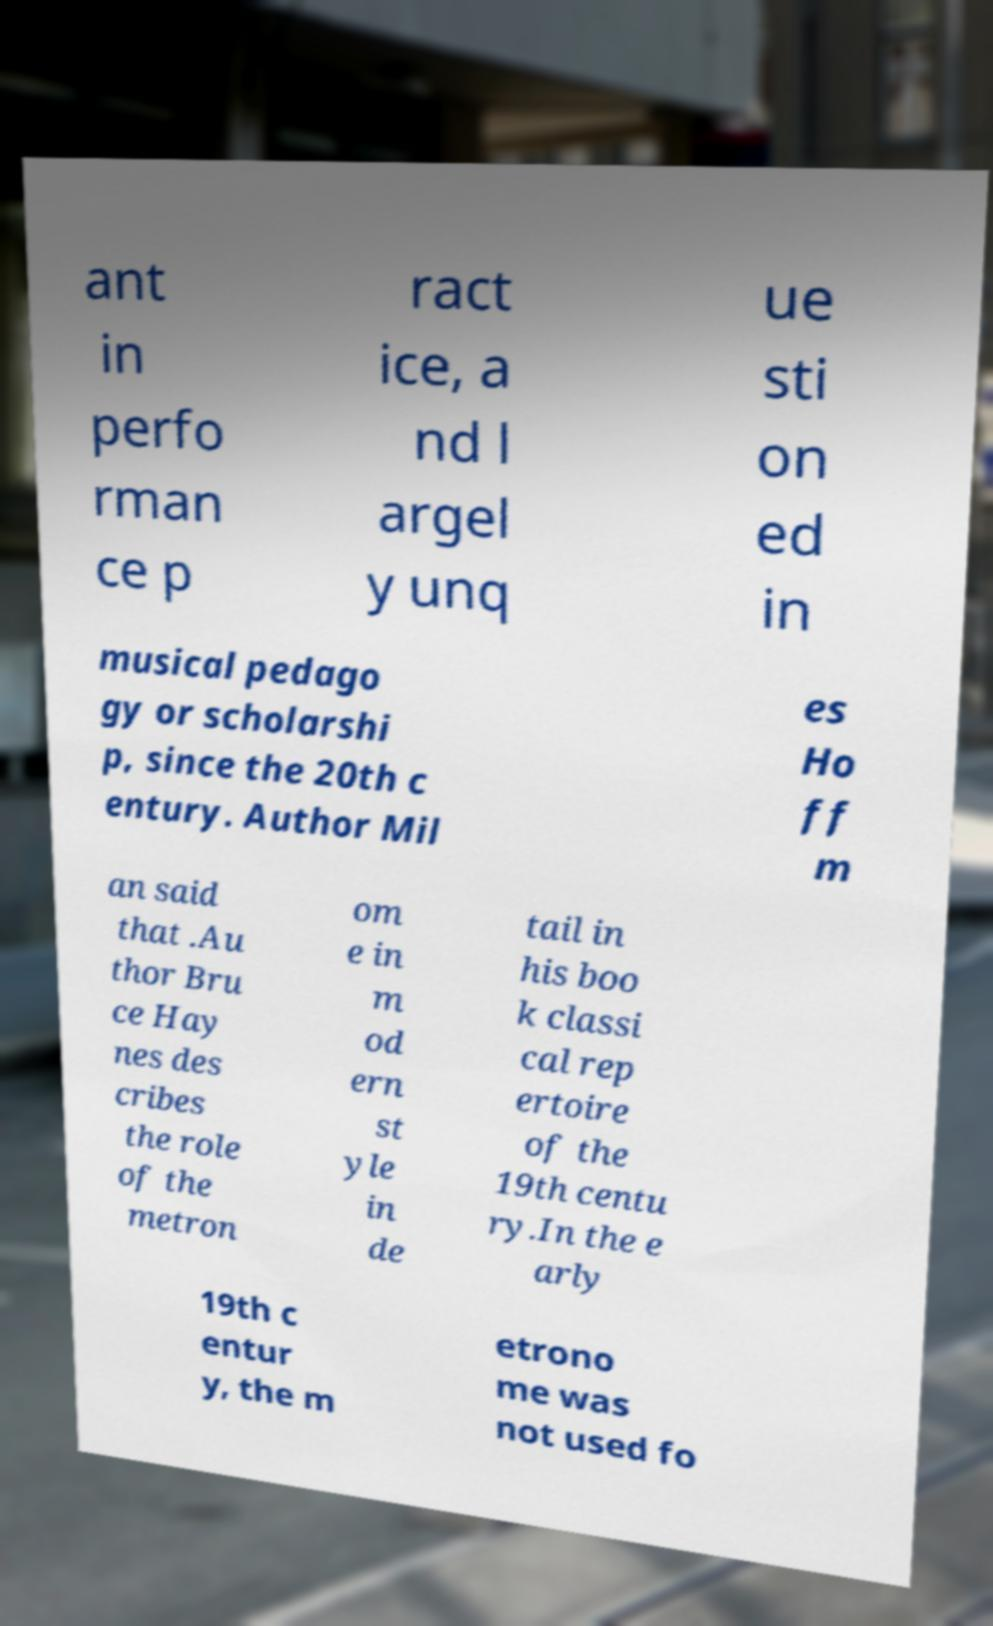Could you extract and type out the text from this image? ant in perfo rman ce p ract ice, a nd l argel y unq ue sti on ed in musical pedago gy or scholarshi p, since the 20th c entury. Author Mil es Ho ff m an said that .Au thor Bru ce Hay nes des cribes the role of the metron om e in m od ern st yle in de tail in his boo k classi cal rep ertoire of the 19th centu ry.In the e arly 19th c entur y, the m etrono me was not used fo 